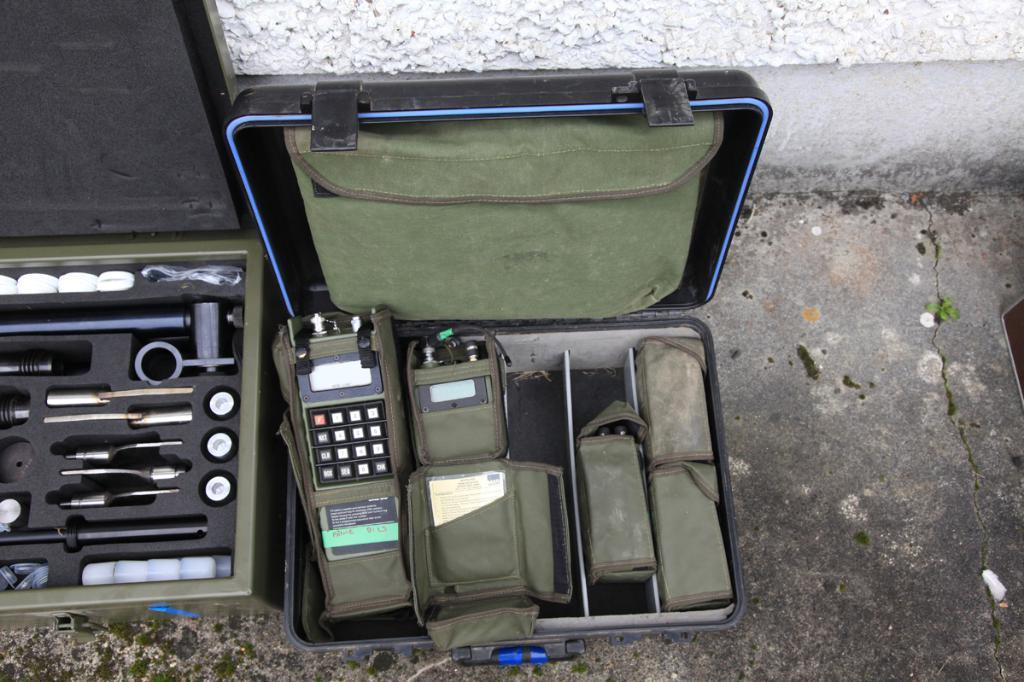What objects can be seen in the image? There are briefcases in the image. What is inside the briefcases? Some devices are present in one of the briefcases, and some tools are present in the other briefcase. What can be seen below the briefcases in the image? The ground is visible in the image. What is located behind the briefcases in the image? There is a wall in the image. What type of loaf is being prepared on the stage in the image? There is no stage, loaf, or any indication of food preparation in the image. 